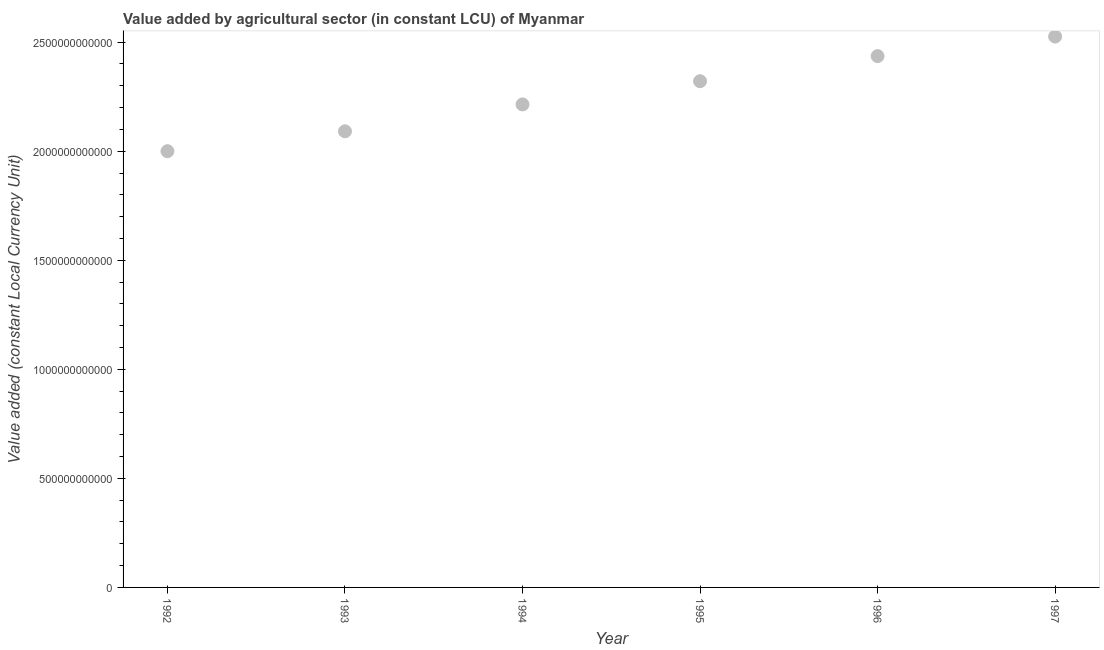What is the value added by agriculture sector in 1997?
Your answer should be compact. 2.53e+12. Across all years, what is the maximum value added by agriculture sector?
Offer a terse response. 2.53e+12. Across all years, what is the minimum value added by agriculture sector?
Make the answer very short. 2.00e+12. What is the sum of the value added by agriculture sector?
Make the answer very short. 1.36e+13. What is the difference between the value added by agriculture sector in 1995 and 1997?
Your response must be concise. -2.05e+11. What is the average value added by agriculture sector per year?
Offer a terse response. 2.26e+12. What is the median value added by agriculture sector?
Make the answer very short. 2.27e+12. Do a majority of the years between 1997 and 1994 (inclusive) have value added by agriculture sector greater than 1400000000000 LCU?
Keep it short and to the point. Yes. What is the ratio of the value added by agriculture sector in 1992 to that in 1994?
Provide a succinct answer. 0.9. Is the difference between the value added by agriculture sector in 1992 and 1995 greater than the difference between any two years?
Your response must be concise. No. What is the difference between the highest and the second highest value added by agriculture sector?
Your response must be concise. 8.96e+1. Is the sum of the value added by agriculture sector in 1996 and 1997 greater than the maximum value added by agriculture sector across all years?
Offer a terse response. Yes. What is the difference between the highest and the lowest value added by agriculture sector?
Ensure brevity in your answer.  5.26e+11. In how many years, is the value added by agriculture sector greater than the average value added by agriculture sector taken over all years?
Offer a terse response. 3. How many years are there in the graph?
Keep it short and to the point. 6. What is the difference between two consecutive major ticks on the Y-axis?
Make the answer very short. 5.00e+11. Does the graph contain any zero values?
Keep it short and to the point. No. What is the title of the graph?
Your answer should be compact. Value added by agricultural sector (in constant LCU) of Myanmar. What is the label or title of the X-axis?
Give a very brief answer. Year. What is the label or title of the Y-axis?
Your answer should be very brief. Value added (constant Local Currency Unit). What is the Value added (constant Local Currency Unit) in 1992?
Your response must be concise. 2.00e+12. What is the Value added (constant Local Currency Unit) in 1993?
Your answer should be very brief. 2.09e+12. What is the Value added (constant Local Currency Unit) in 1994?
Your response must be concise. 2.21e+12. What is the Value added (constant Local Currency Unit) in 1995?
Offer a terse response. 2.32e+12. What is the Value added (constant Local Currency Unit) in 1996?
Ensure brevity in your answer.  2.44e+12. What is the Value added (constant Local Currency Unit) in 1997?
Your answer should be compact. 2.53e+12. What is the difference between the Value added (constant Local Currency Unit) in 1992 and 1993?
Keep it short and to the point. -9.11e+1. What is the difference between the Value added (constant Local Currency Unit) in 1992 and 1994?
Offer a terse response. -2.14e+11. What is the difference between the Value added (constant Local Currency Unit) in 1992 and 1995?
Provide a succinct answer. -3.21e+11. What is the difference between the Value added (constant Local Currency Unit) in 1992 and 1996?
Keep it short and to the point. -4.36e+11. What is the difference between the Value added (constant Local Currency Unit) in 1992 and 1997?
Your answer should be compact. -5.26e+11. What is the difference between the Value added (constant Local Currency Unit) in 1993 and 1994?
Your response must be concise. -1.23e+11. What is the difference between the Value added (constant Local Currency Unit) in 1993 and 1995?
Your answer should be very brief. -2.30e+11. What is the difference between the Value added (constant Local Currency Unit) in 1993 and 1996?
Give a very brief answer. -3.45e+11. What is the difference between the Value added (constant Local Currency Unit) in 1993 and 1997?
Your answer should be very brief. -4.34e+11. What is the difference between the Value added (constant Local Currency Unit) in 1994 and 1995?
Give a very brief answer. -1.06e+11. What is the difference between the Value added (constant Local Currency Unit) in 1994 and 1996?
Your answer should be compact. -2.22e+11. What is the difference between the Value added (constant Local Currency Unit) in 1994 and 1997?
Give a very brief answer. -3.11e+11. What is the difference between the Value added (constant Local Currency Unit) in 1995 and 1996?
Provide a short and direct response. -1.15e+11. What is the difference between the Value added (constant Local Currency Unit) in 1995 and 1997?
Offer a very short reply. -2.05e+11. What is the difference between the Value added (constant Local Currency Unit) in 1996 and 1997?
Give a very brief answer. -8.96e+1. What is the ratio of the Value added (constant Local Currency Unit) in 1992 to that in 1993?
Provide a succinct answer. 0.96. What is the ratio of the Value added (constant Local Currency Unit) in 1992 to that in 1994?
Ensure brevity in your answer.  0.9. What is the ratio of the Value added (constant Local Currency Unit) in 1992 to that in 1995?
Your answer should be very brief. 0.86. What is the ratio of the Value added (constant Local Currency Unit) in 1992 to that in 1996?
Provide a succinct answer. 0.82. What is the ratio of the Value added (constant Local Currency Unit) in 1992 to that in 1997?
Your answer should be compact. 0.79. What is the ratio of the Value added (constant Local Currency Unit) in 1993 to that in 1994?
Your answer should be very brief. 0.94. What is the ratio of the Value added (constant Local Currency Unit) in 1993 to that in 1995?
Make the answer very short. 0.9. What is the ratio of the Value added (constant Local Currency Unit) in 1993 to that in 1996?
Give a very brief answer. 0.86. What is the ratio of the Value added (constant Local Currency Unit) in 1993 to that in 1997?
Offer a very short reply. 0.83. What is the ratio of the Value added (constant Local Currency Unit) in 1994 to that in 1995?
Keep it short and to the point. 0.95. What is the ratio of the Value added (constant Local Currency Unit) in 1994 to that in 1996?
Your answer should be compact. 0.91. What is the ratio of the Value added (constant Local Currency Unit) in 1994 to that in 1997?
Keep it short and to the point. 0.88. What is the ratio of the Value added (constant Local Currency Unit) in 1995 to that in 1996?
Make the answer very short. 0.95. What is the ratio of the Value added (constant Local Currency Unit) in 1995 to that in 1997?
Give a very brief answer. 0.92. 